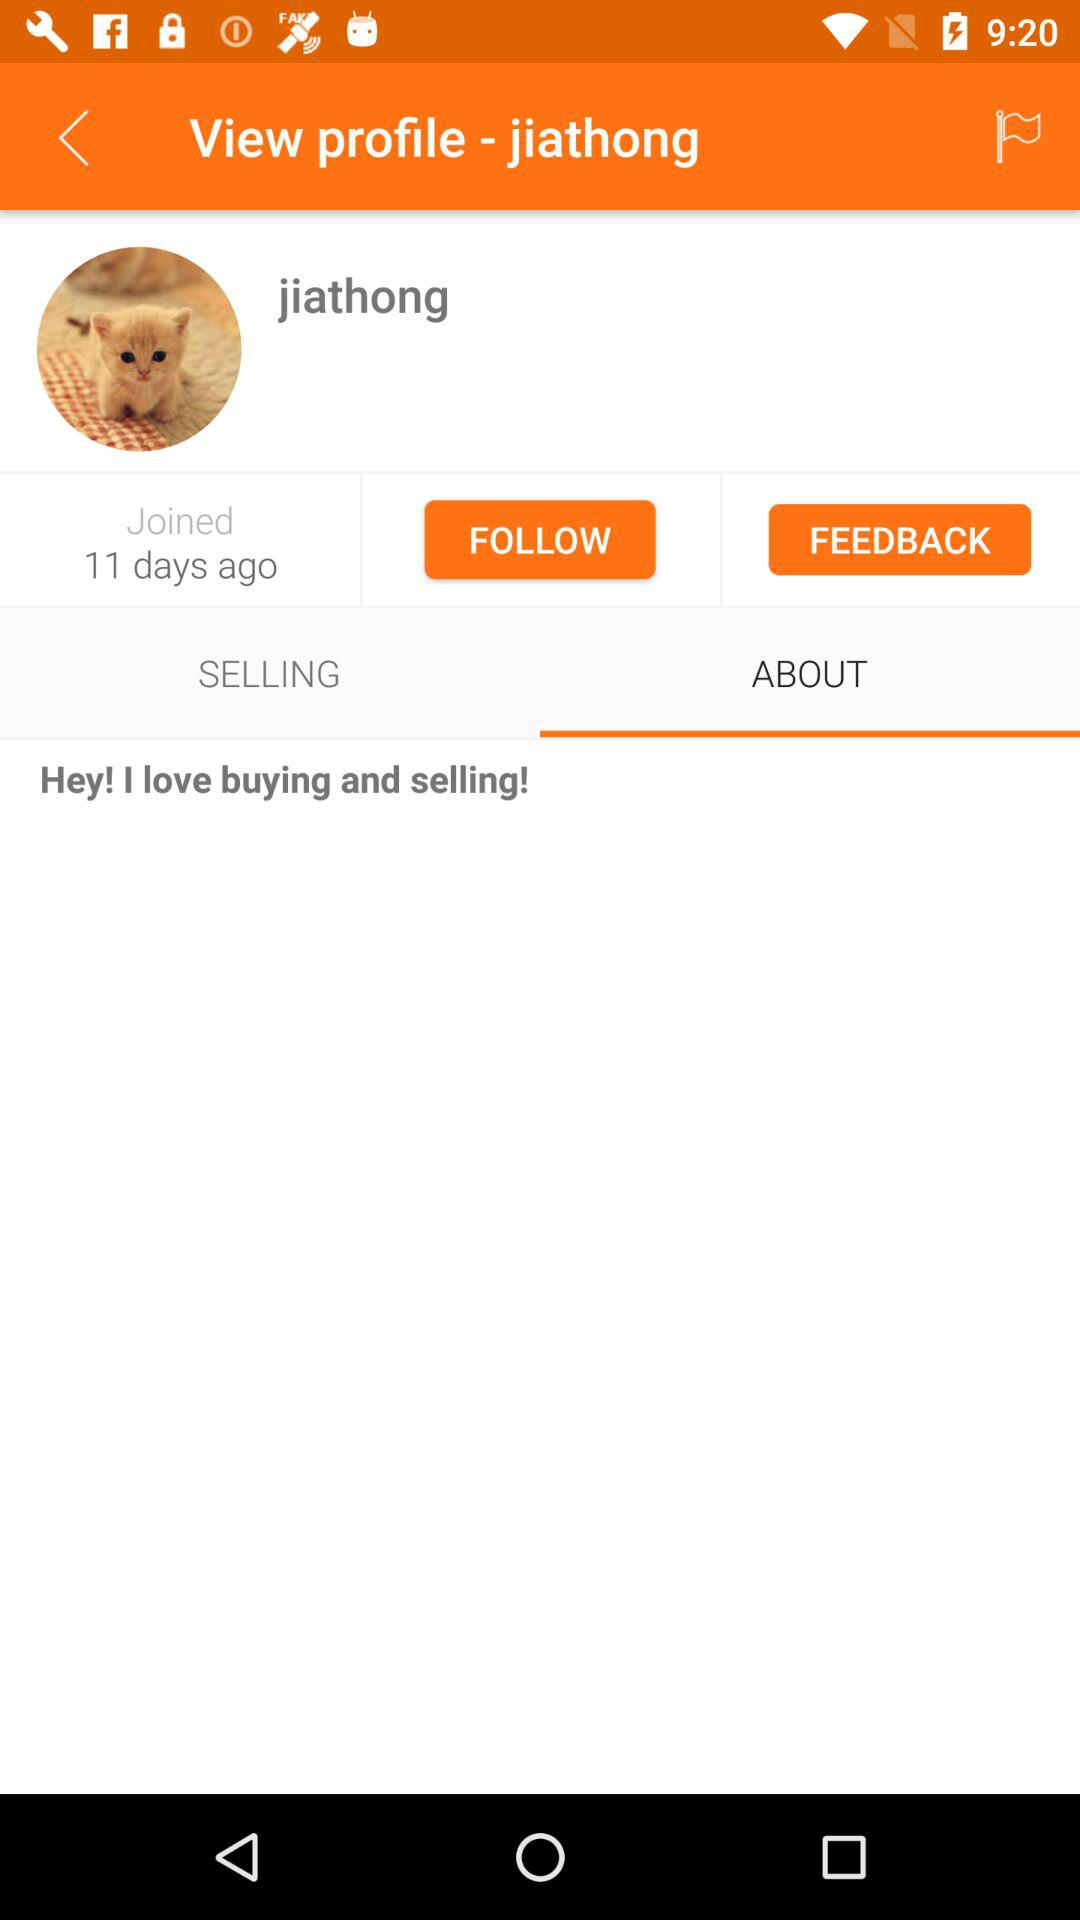When did the user join? The user joined 11 days ago. 